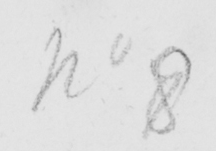Please provide the text content of this handwritten line. No 8 